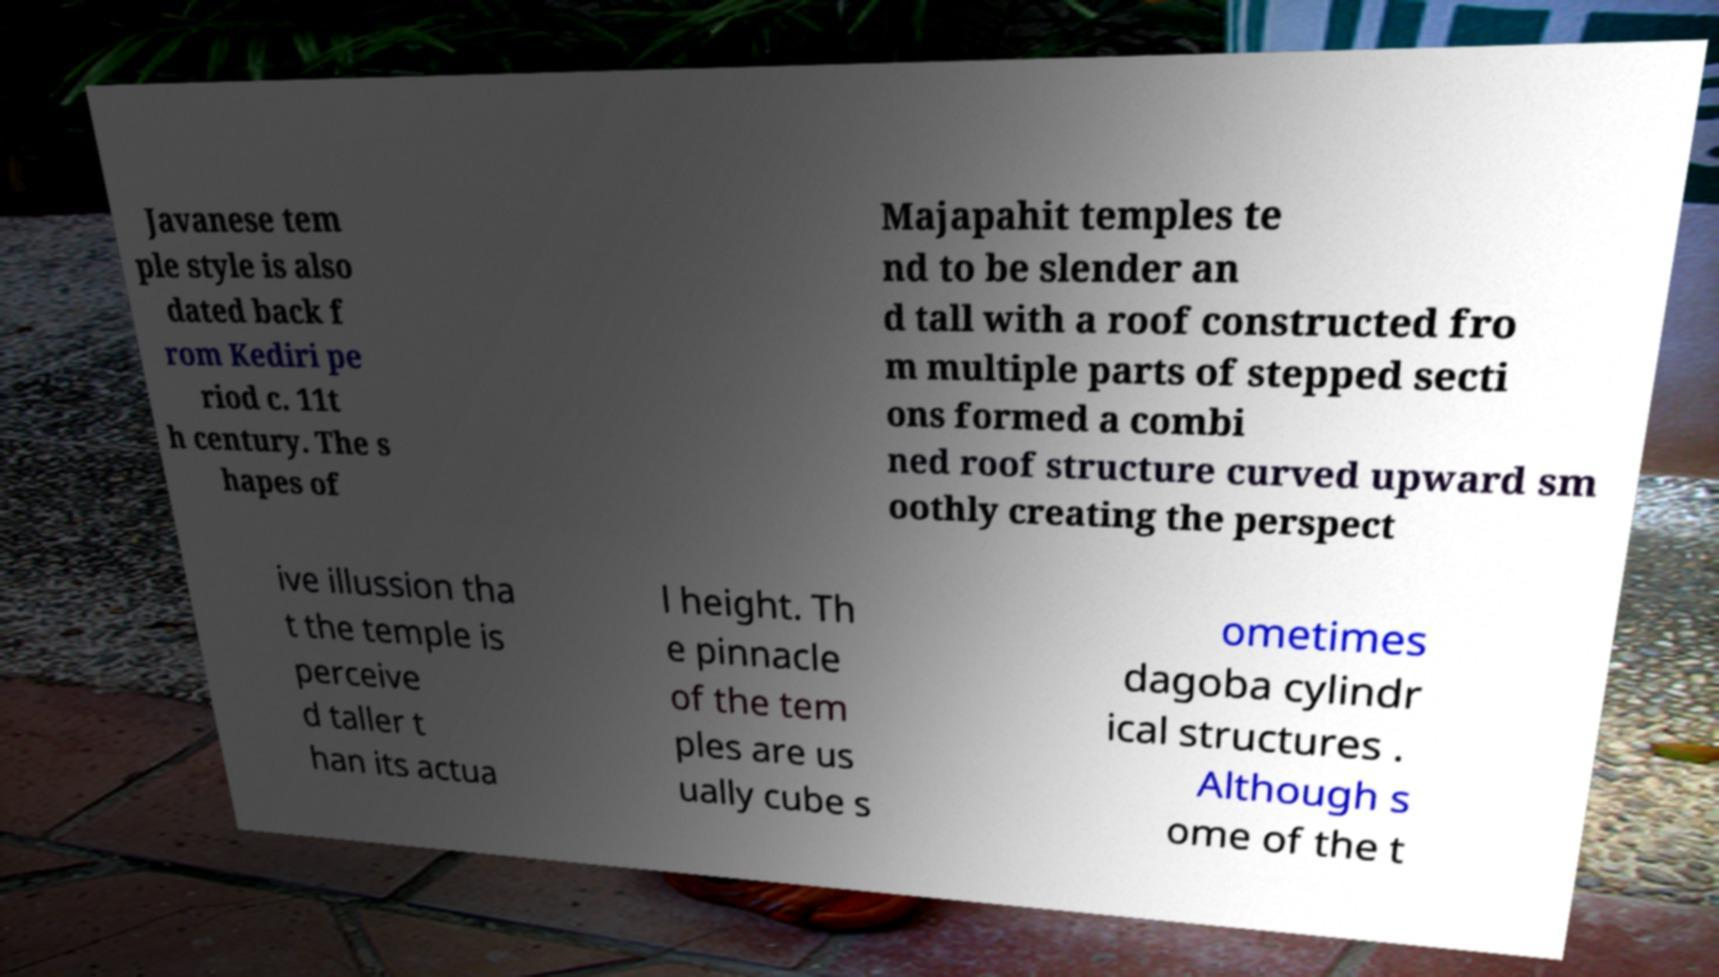I need the written content from this picture converted into text. Can you do that? Javanese tem ple style is also dated back f rom Kediri pe riod c. 11t h century. The s hapes of Majapahit temples te nd to be slender an d tall with a roof constructed fro m multiple parts of stepped secti ons formed a combi ned roof structure curved upward sm oothly creating the perspect ive illussion tha t the temple is perceive d taller t han its actua l height. Th e pinnacle of the tem ples are us ually cube s ometimes dagoba cylindr ical structures . Although s ome of the t 